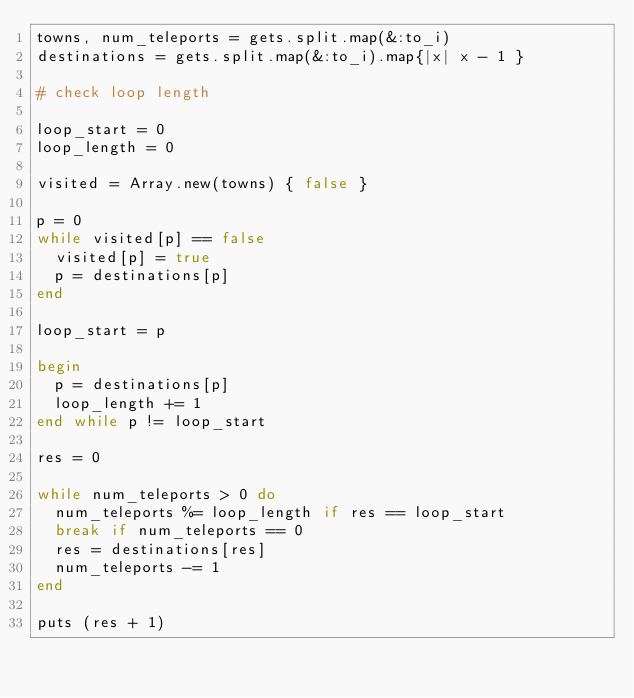Convert code to text. <code><loc_0><loc_0><loc_500><loc_500><_Ruby_>towns, num_teleports = gets.split.map(&:to_i)
destinations = gets.split.map(&:to_i).map{|x| x - 1 }

# check loop length

loop_start = 0
loop_length = 0

visited = Array.new(towns) { false }

p = 0
while visited[p] == false
  visited[p] = true
  p = destinations[p]
end

loop_start = p

begin
  p = destinations[p]
  loop_length += 1
end while p != loop_start

res = 0

while num_teleports > 0 do
  num_teleports %= loop_length if res == loop_start
  break if num_teleports == 0
  res = destinations[res]
  num_teleports -= 1
end

puts (res + 1)</code> 